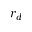<formula> <loc_0><loc_0><loc_500><loc_500>r _ { d }</formula> 